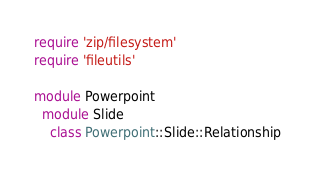<code> <loc_0><loc_0><loc_500><loc_500><_Ruby_>require 'zip/filesystem'
require 'fileutils'

module Powerpoint
  module Slide
    class Powerpoint::Slide::Relationship</code> 